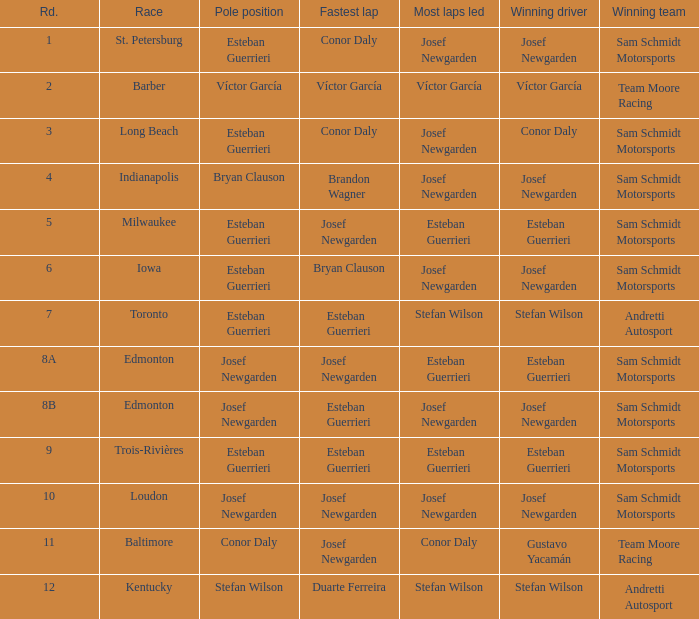Who recorded the fastest lap(s) during stefan wilson's pole position? Duarte Ferreira. 